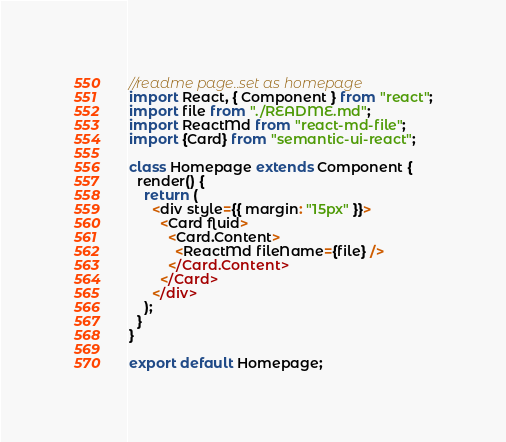<code> <loc_0><loc_0><loc_500><loc_500><_JavaScript_>//readme page..set as homepage
import React, { Component } from "react";
import file from "./README.md";
import ReactMd from "react-md-file";
import {Card} from "semantic-ui-react";

class Homepage extends Component {
  render() {
    return (
      <div style={{ margin: "15px" }}>
        <Card fluid>
          <Card.Content>
            <ReactMd fileName={file} />
          </Card.Content>
        </Card>
      </div>
    );
  }
}

export default Homepage;
</code> 